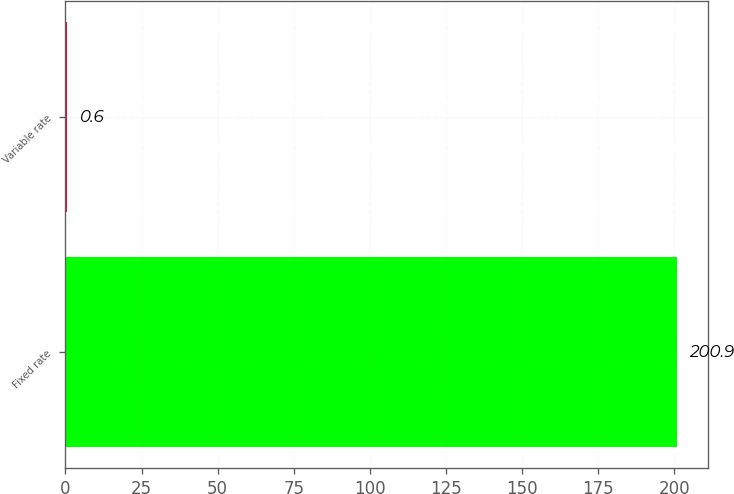<chart> <loc_0><loc_0><loc_500><loc_500><bar_chart><fcel>Fixed rate<fcel>Variable rate<nl><fcel>200.9<fcel>0.6<nl></chart> 